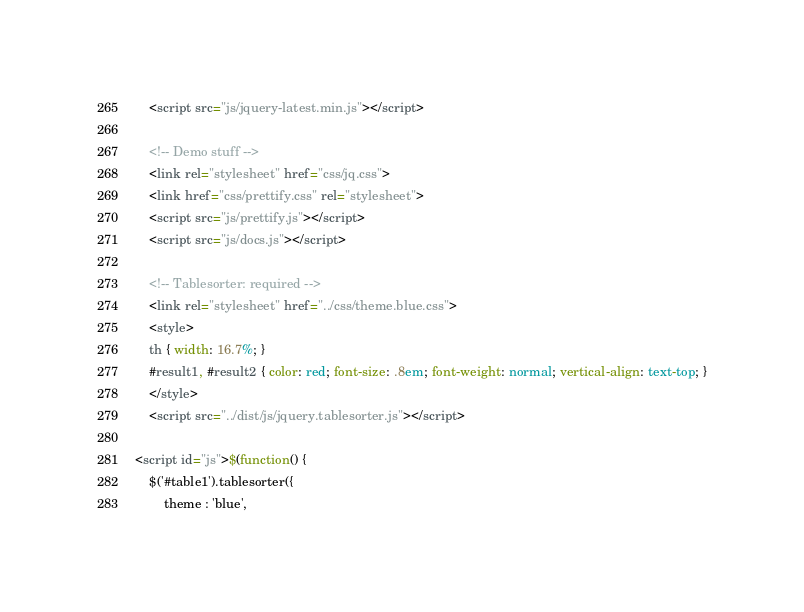<code> <loc_0><loc_0><loc_500><loc_500><_HTML_>	<script src="js/jquery-latest.min.js"></script>

	<!-- Demo stuff -->
	<link rel="stylesheet" href="css/jq.css">
	<link href="css/prettify.css" rel="stylesheet">
	<script src="js/prettify.js"></script>
	<script src="js/docs.js"></script>

	<!-- Tablesorter: required -->
	<link rel="stylesheet" href="../css/theme.blue.css">
	<style>
	th { width: 16.7%; }
	#result1, #result2 { color: red; font-size: .8em; font-weight: normal; vertical-align: text-top; }
	</style>
	<script src="../dist/js/jquery.tablesorter.js"></script>

<script id="js">$(function() {
	$('#table1').tablesorter({
		theme : 'blue',
</code> 